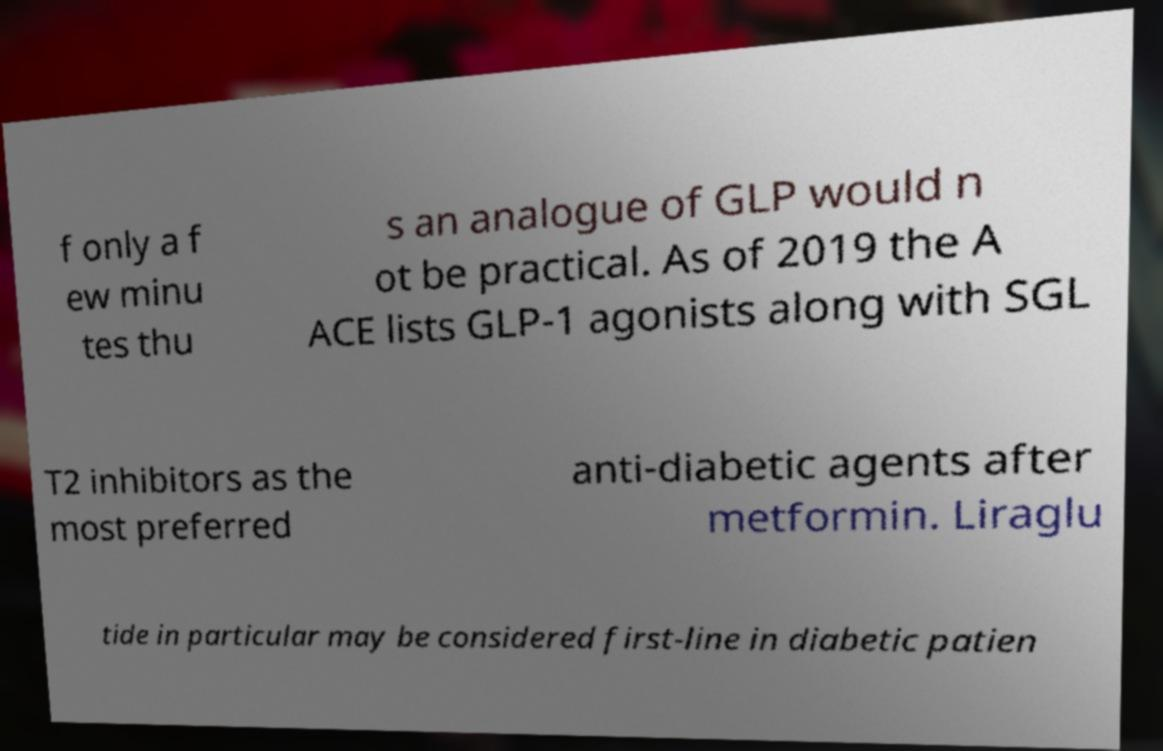Can you read and provide the text displayed in the image?This photo seems to have some interesting text. Can you extract and type it out for me? f only a f ew minu tes thu s an analogue of GLP would n ot be practical. As of 2019 the A ACE lists GLP-1 agonists along with SGL T2 inhibitors as the most preferred anti-diabetic agents after metformin. Liraglu tide in particular may be considered first-line in diabetic patien 